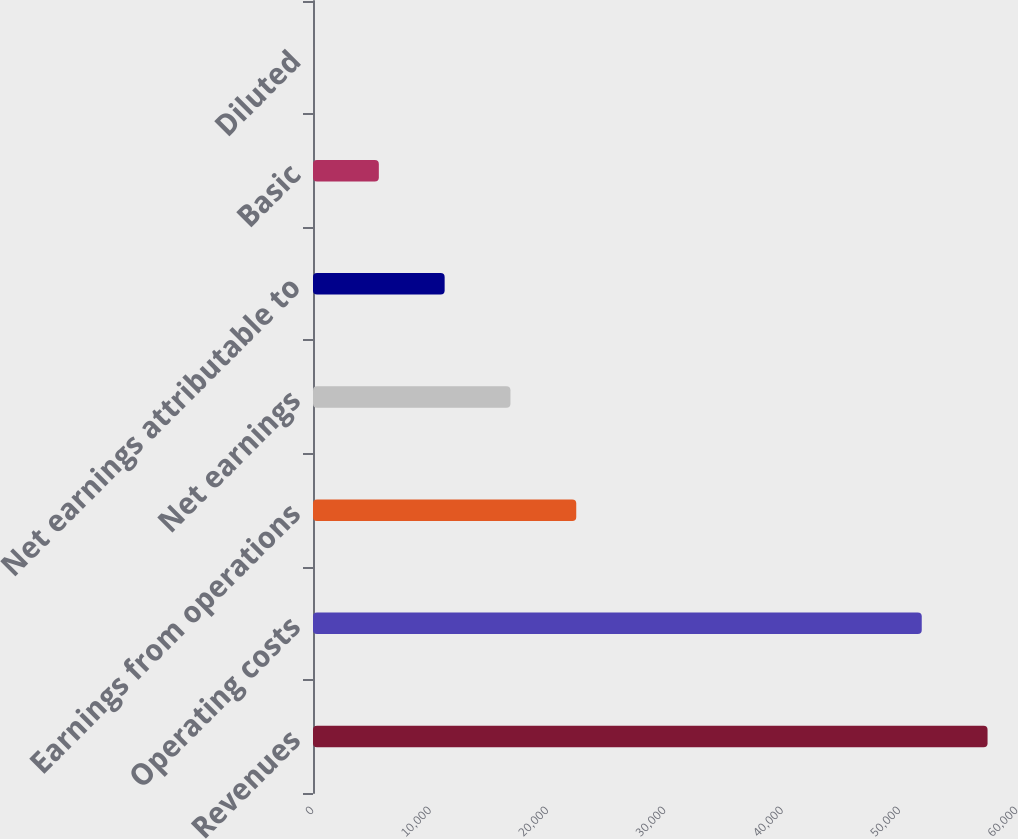Convert chart. <chart><loc_0><loc_0><loc_500><loc_500><bar_chart><fcel>Revenues<fcel>Operating costs<fcel>Earnings from operations<fcel>Net earnings<fcel>Net earnings attributable to<fcel>Basic<fcel>Diluted<nl><fcel>57490.3<fcel>51882<fcel>22436.2<fcel>16827.9<fcel>11219.6<fcel>5611.28<fcel>2.98<nl></chart> 